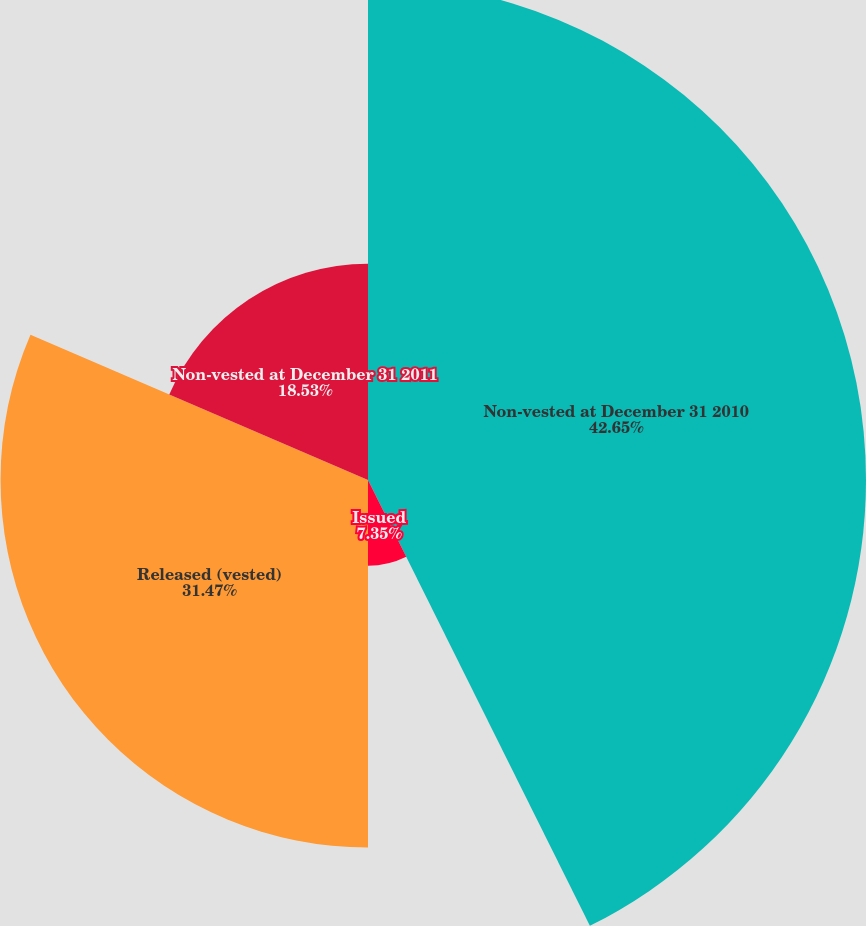<chart> <loc_0><loc_0><loc_500><loc_500><pie_chart><fcel>Non-vested at December 31 2010<fcel>Issued<fcel>Released (vested)<fcel>Non-vested at December 31 2011<nl><fcel>42.65%<fcel>7.35%<fcel>31.47%<fcel>18.53%<nl></chart> 